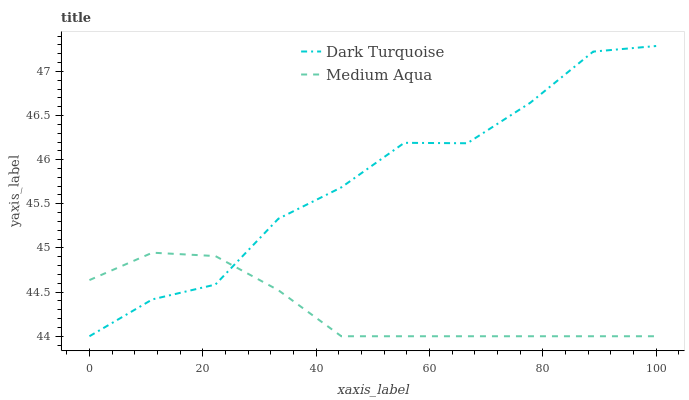Does Medium Aqua have the minimum area under the curve?
Answer yes or no. Yes. Does Dark Turquoise have the maximum area under the curve?
Answer yes or no. Yes. Does Medium Aqua have the maximum area under the curve?
Answer yes or no. No. Is Medium Aqua the smoothest?
Answer yes or no. Yes. Is Dark Turquoise the roughest?
Answer yes or no. Yes. Is Medium Aqua the roughest?
Answer yes or no. No. Does Dark Turquoise have the lowest value?
Answer yes or no. Yes. Does Dark Turquoise have the highest value?
Answer yes or no. Yes. Does Medium Aqua have the highest value?
Answer yes or no. No. Does Dark Turquoise intersect Medium Aqua?
Answer yes or no. Yes. Is Dark Turquoise less than Medium Aqua?
Answer yes or no. No. Is Dark Turquoise greater than Medium Aqua?
Answer yes or no. No. 